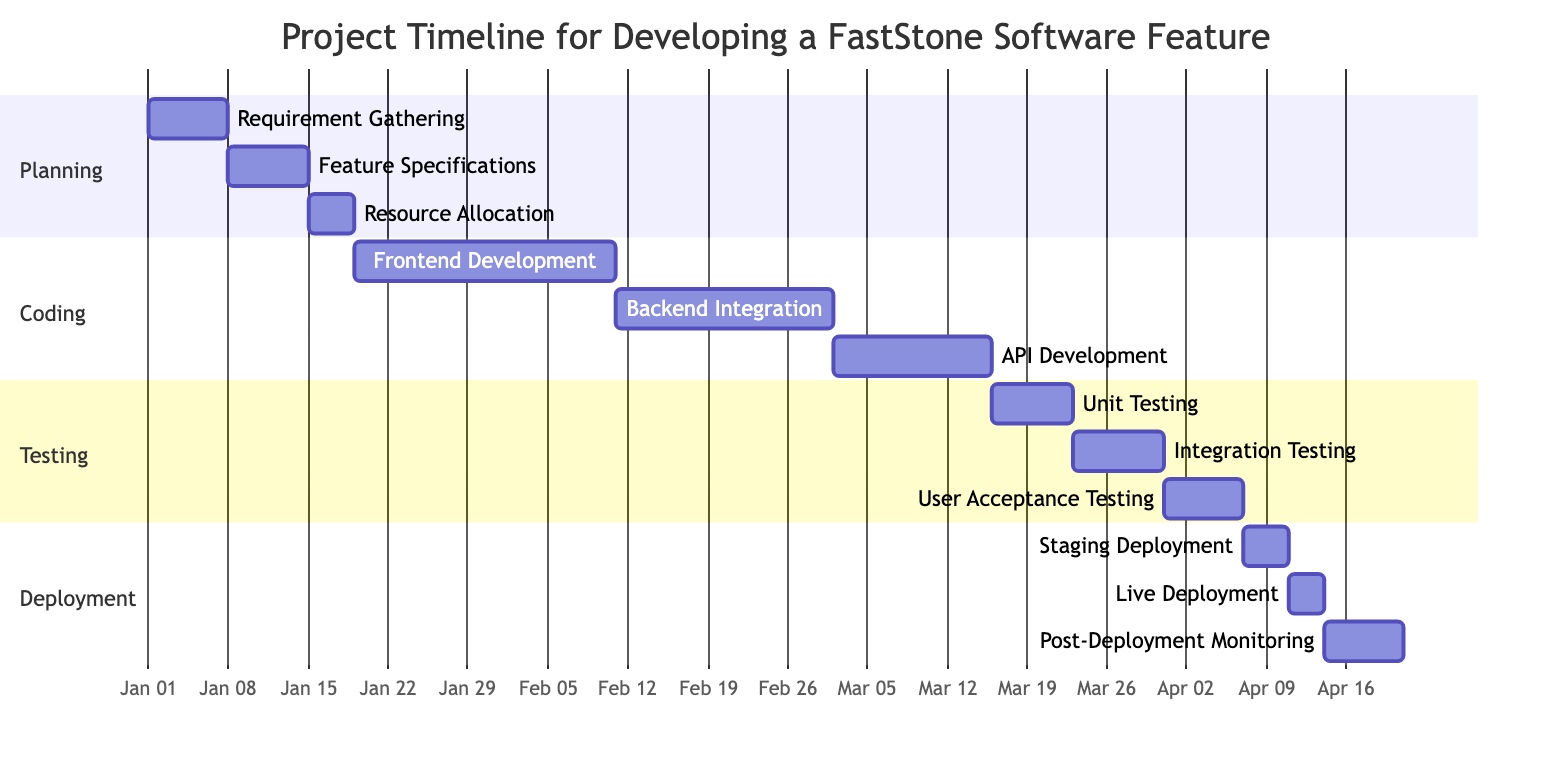What is the duration of the Requirement Gathering task? The Requirement Gathering task starts on January 1, 2023, and ends on January 7, 2023. To find the duration, we calculate the difference between these two dates, which is 7 days.
Answer: 7 days How many tasks are included in the Coding section? The Coding section has three tasks listed: Frontend Development, Backend Integration, and API Development. Thus, the total count of tasks is three.
Answer: 3 Which task follows Feature Specifications in the timeline? Feature Specifications ends on January 14, 2023. The next task is Resource Allocation, which starts on January 15, 2023, directly after Feature Specifications.
Answer: Resource Allocation What is the last task in the Testing stage? The last task listed in the Testing stage is User Acceptance Testing, which occurs from March 31, 2023, to April 6, 2023.
Answer: User Acceptance Testing What is the total duration of the Deployment stage? The Deployment stage consists of three tasks - Staging Deployment, Live Deployment, and Post-Deployment Monitoring. Their respective durations are 4 days, 3 days, and 7 days. Adding these gives us a total of 14 days for the entire Deployment stage.
Answer: 14 days Which task has the longest duration in the Coding section? In the Coding section, the Frontend Development task has a duration of 23 days, whereas Backend Integration has 19 days and API Development has 14 days. Thus, Frontend Development is the longest.
Answer: Frontend Development During which day does Post-Deployment Monitoring start? Post-Deployment Monitoring starts on April 14, 2023. This is directly noted from the task's timing in the Gantt chart.
Answer: April 14, 2023 What is the time gap between the end of Unit Testing and the start of Staging Deployment? Unit Testing ends on March 22, 2023, and Staging Deployment starts on April 7, 2023. The gap between these dates is 15 days.
Answer: 15 days How many days are allocated for Backend Integration? The Backend Integration task lasts from February 11, 2023, to March 1, 2023. Counting the days between these two dates gives us a duration of 19 days.
Answer: 19 days 